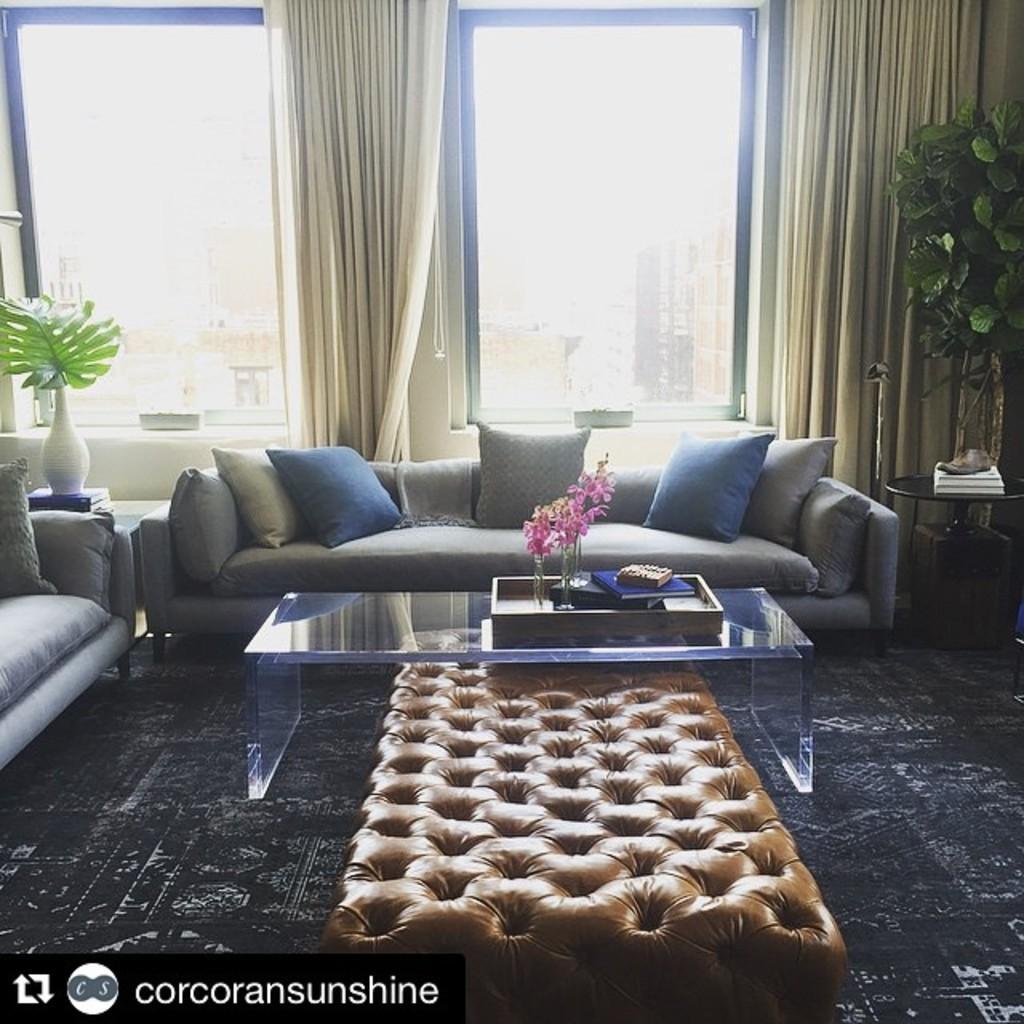In one or two sentences, can you explain what this image depicts? This is a room in which sofa,table,house plant,window,curtain are there. 